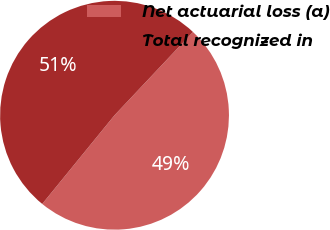Convert chart. <chart><loc_0><loc_0><loc_500><loc_500><pie_chart><fcel>Net actuarial loss (a)<fcel>Total recognized in<nl><fcel>48.86%<fcel>51.14%<nl></chart> 